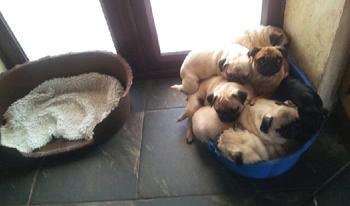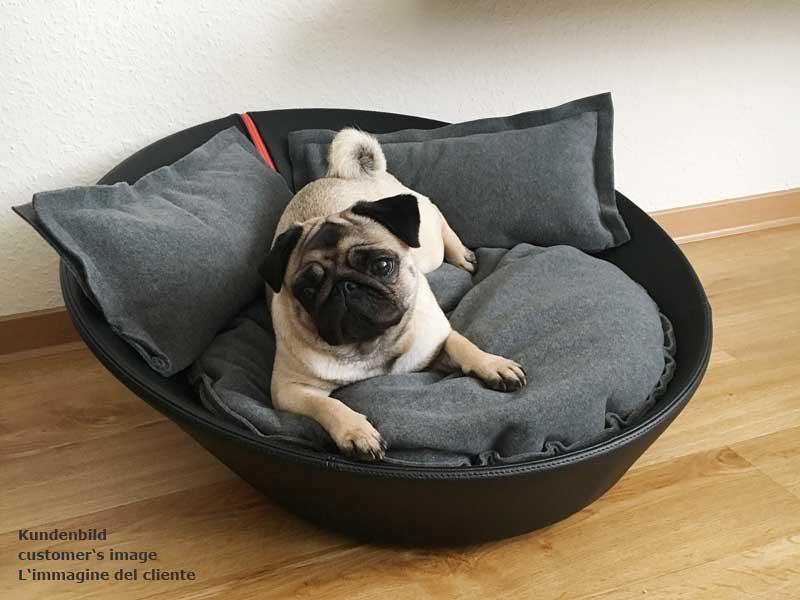The first image is the image on the left, the second image is the image on the right. Analyze the images presented: Is the assertion "There are at least four pugs." valid? Answer yes or no. Yes. The first image is the image on the left, the second image is the image on the right. Evaluate the accuracy of this statement regarding the images: "All dogs are in soft-sided containers, and all dogs are light tan with dark faces.". Is it true? Answer yes or no. Yes. 